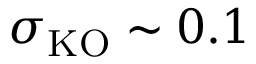<formula> <loc_0><loc_0><loc_500><loc_500>\sigma _ { K O } \sim 0 . 1</formula> 